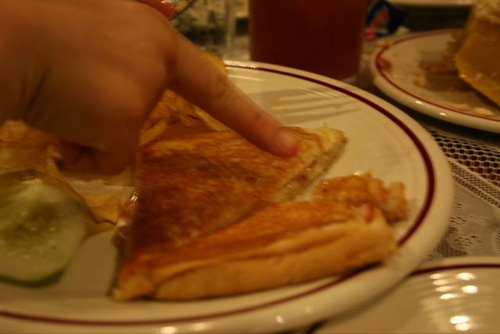Describe the objects in this image and their specific colors. I can see dining table in brown, maroon, tan, and black tones, pizza in maroon, brown, and orange tones, people in maroon and brown tones, sandwich in maroon and brown tones, and sandwich in maroon, brown, and orange tones in this image. 